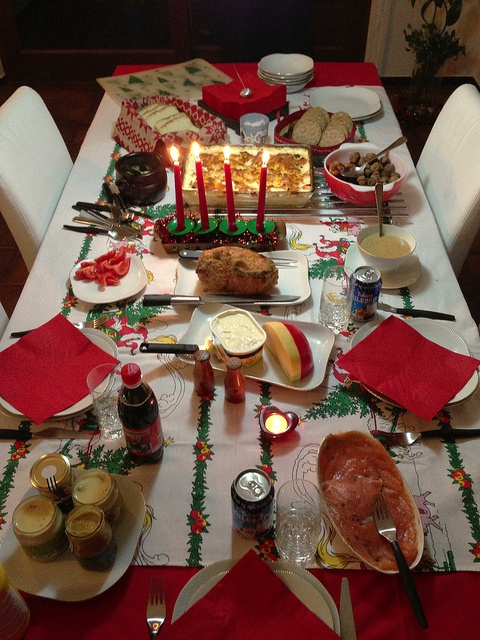Describe the objects in this image and their specific colors. I can see dining table in black, maroon, darkgray, and brown tones, chair in black, darkgray, lightgray, and gray tones, chair in black, lightgray, darkgray, and gray tones, cake in black, brown, tan, khaki, and gray tones, and bowl in black, maroon, and brown tones in this image. 